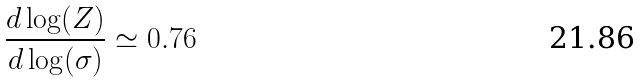<formula> <loc_0><loc_0><loc_500><loc_500>\frac { d \log ( Z ) } { d \log ( \sigma ) } \simeq 0 . 7 6</formula> 